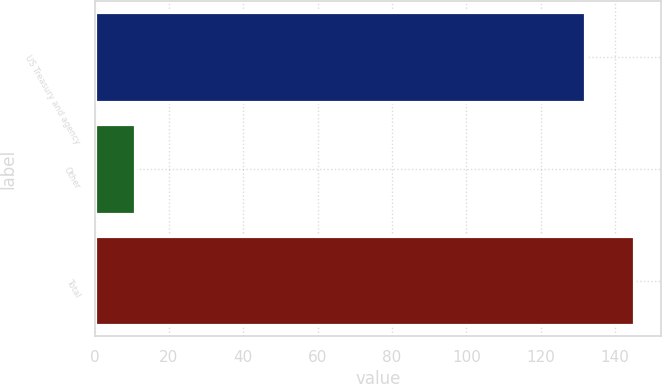Convert chart to OTSL. <chart><loc_0><loc_0><loc_500><loc_500><bar_chart><fcel>US Treasury and agency<fcel>Other<fcel>Total<nl><fcel>132<fcel>11<fcel>145.2<nl></chart> 